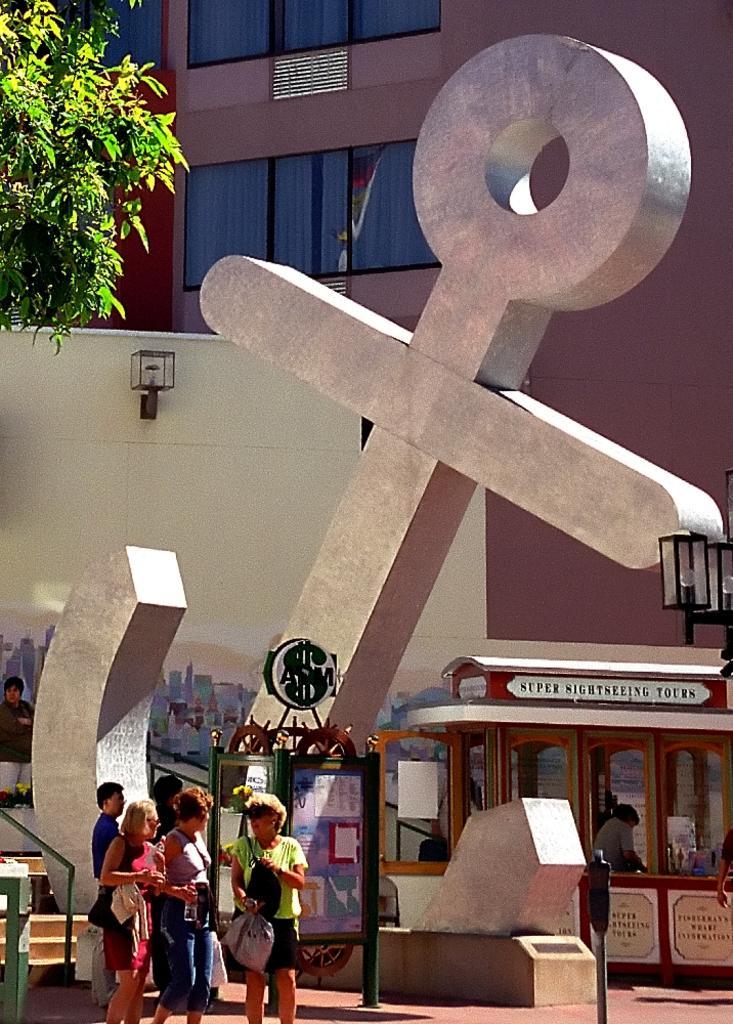Could you give a brief overview of what you see in this image? In this image I can see an anchor shaped statue. Also there are group of people, there are lights,there is a vehicle, a wall, a tree and in the background there is a building. 